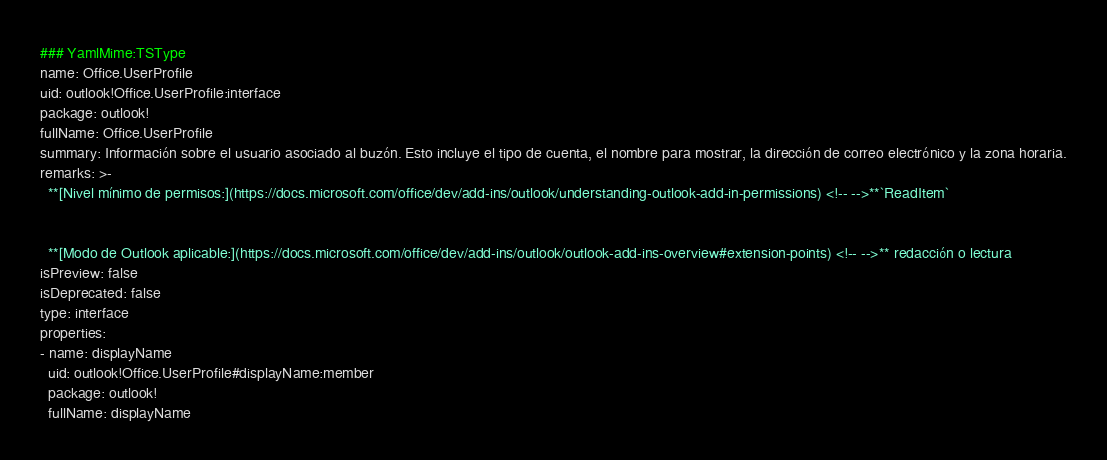Convert code to text. <code><loc_0><loc_0><loc_500><loc_500><_YAML_>### YamlMime:TSType
name: Office.UserProfile
uid: outlook!Office.UserProfile:interface
package: outlook!
fullName: Office.UserProfile
summary: Información sobre el usuario asociado al buzón. Esto incluye el tipo de cuenta, el nombre para mostrar, la dirección de correo electrónico y la zona horaria.
remarks: >-
  **[Nivel mínimo de permisos:](https://docs.microsoft.com/office/dev/add-ins/outlook/understanding-outlook-add-in-permissions) <!-- -->**`ReadItem`


  **[Modo de Outlook aplicable:](https://docs.microsoft.com/office/dev/add-ins/outlook/outlook-add-ins-overview#extension-points) <!-- -->** redacción o lectura
isPreview: false
isDeprecated: false
type: interface
properties:
- name: displayName
  uid: outlook!Office.UserProfile#displayName:member
  package: outlook!
  fullName: displayName</code> 